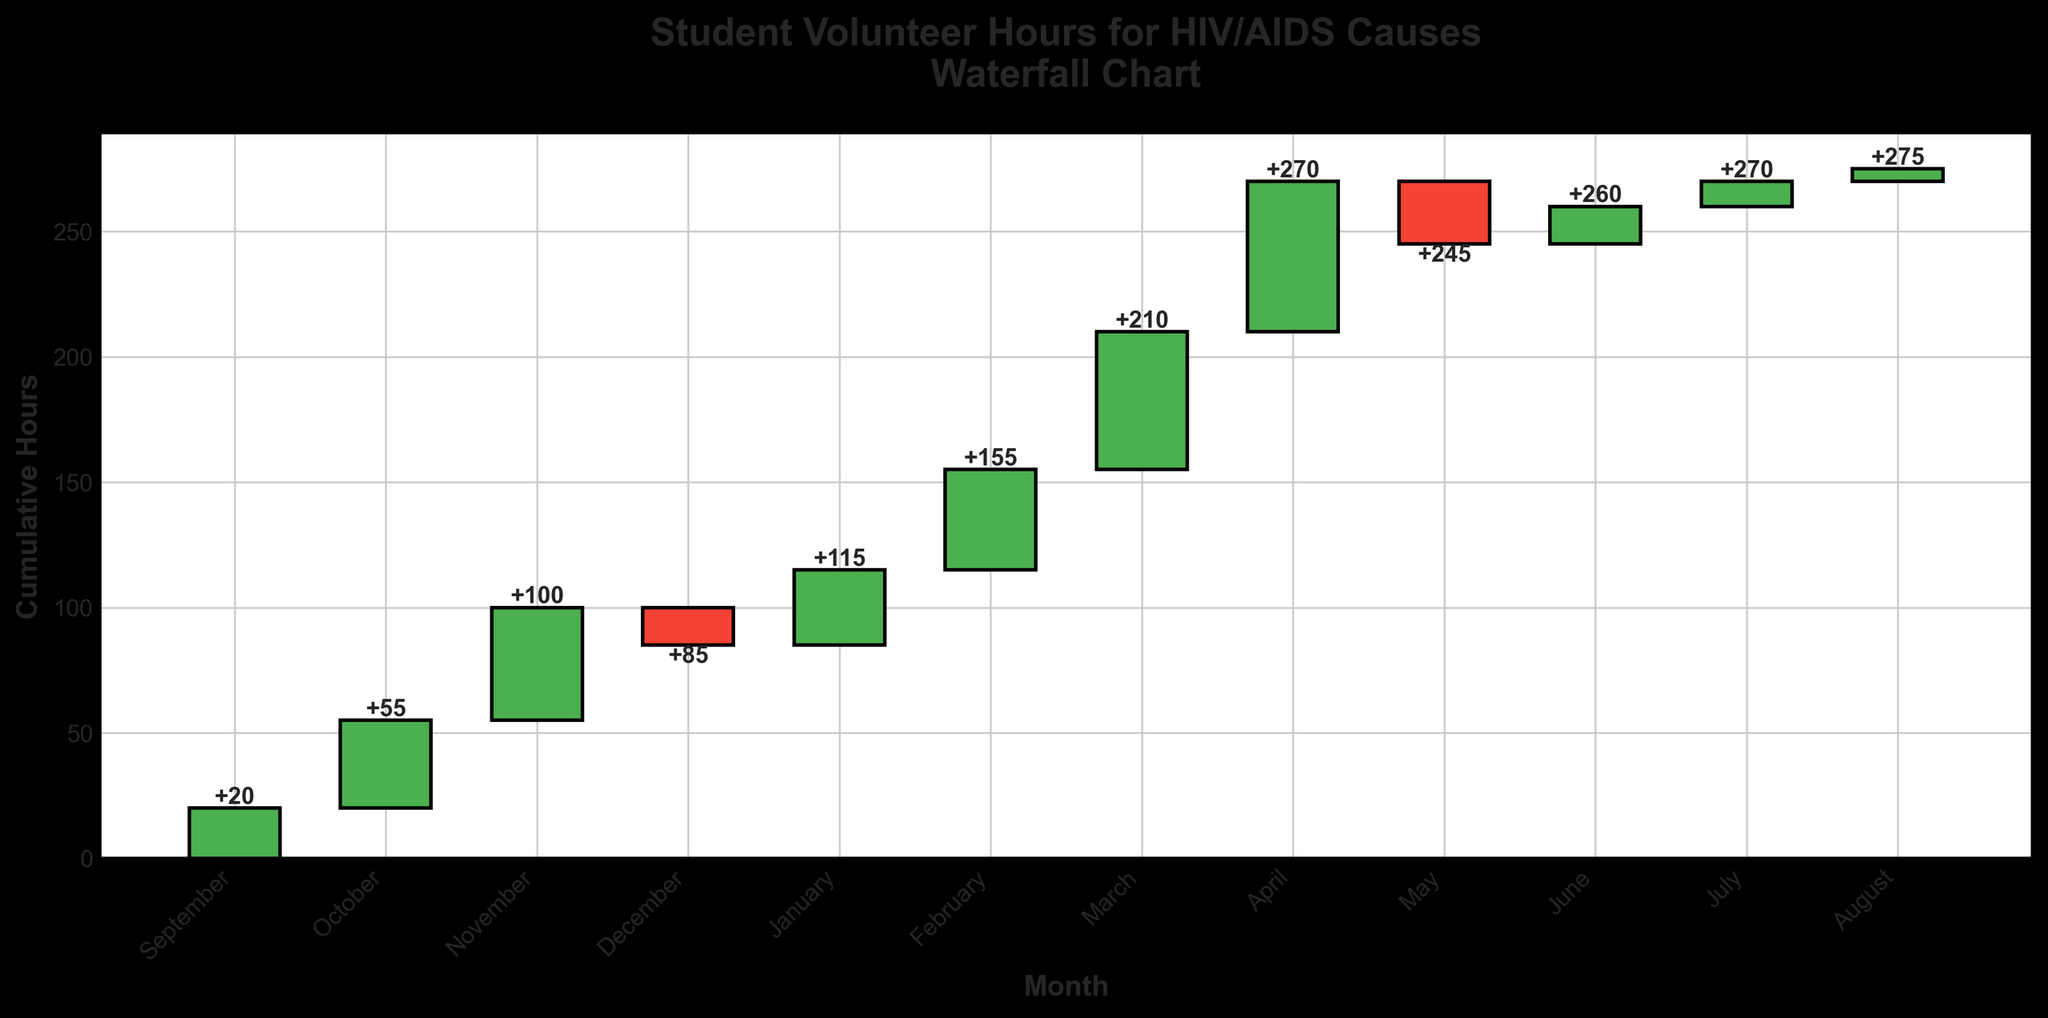What is the title of the plot? The title is prominently displayed at the top of the figure and describes what the chart is about.
Answer: Student Volunteer Hours for HIV/AIDS Causes Waterfall Chart What month had the highest number of volunteer hours? By examining the height of the bars, we can see the month with the tallest green bar, indicating the highest positive value.
Answer: April Which month had a negative impact on cumulative volunteer hours, and how many hours were subtracted in that month? Negative impacts are represented by red bars. By identifying the months with red bars and checking their values, we can determine the impact.
Answer: December and May; 15 hours in December and 25 hours in May What is the cumulative volunteer hour count at the end of March? To find the cumulative hours at the end of March, we look at the cumulative value stated at the top of the March bar.
Answer: 210 hours Compare the number of volunteer hours in October and February. Which month had more, and by how much? By comparing the values of the bars for October and February, we can subtract the lower value from the higher value to find the difference.
Answer: February had more by 5 hours What is the average number of volunteer hours per month in the academic year, excluding the months with negative hours? To calculate the average excluding negative months, sum only the positive hours and divide by the count of positive months.
Answer: (20 + 35 + 45 + 30 + 40 + 55 + 60 + 15 + 10 + 5) / 10 = 31.5 hours What is the cumulative volunteer hour count at the end of the academic year? The cumulative value at the last month's bar (August) indicates the total for the academic year.
Answer: 275 hours What is the difference in cumulative volunteer hours between November and December? To find the difference, subtract the cumulative value at the end of November from the cumulative value at the end of December.
Answer: 85 - 70 = 15 hours In which months did students volunteer fewer total hours than in September? Check the heights and values of bars for each month compared to the September bar.
Answer: December, May, June, July, and August 